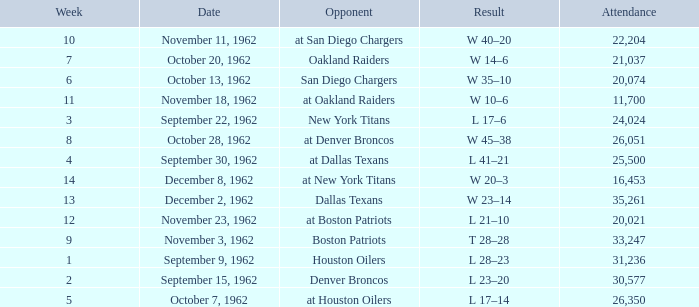What week was the attendance smaller than 22,204 on December 8, 1962? 14.0. 